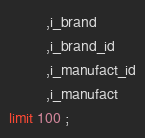<code> <loc_0><loc_0><loc_500><loc_500><_SQL_>         ,i_brand
         ,i_brand_id
         ,i_manufact_id
         ,i_manufact
limit 100 ;


</code> 